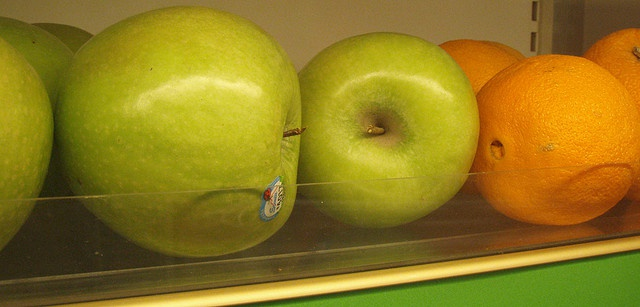Describe the objects in this image and their specific colors. I can see apple in olive and gold tones and orange in olive, orange, red, and maroon tones in this image. 